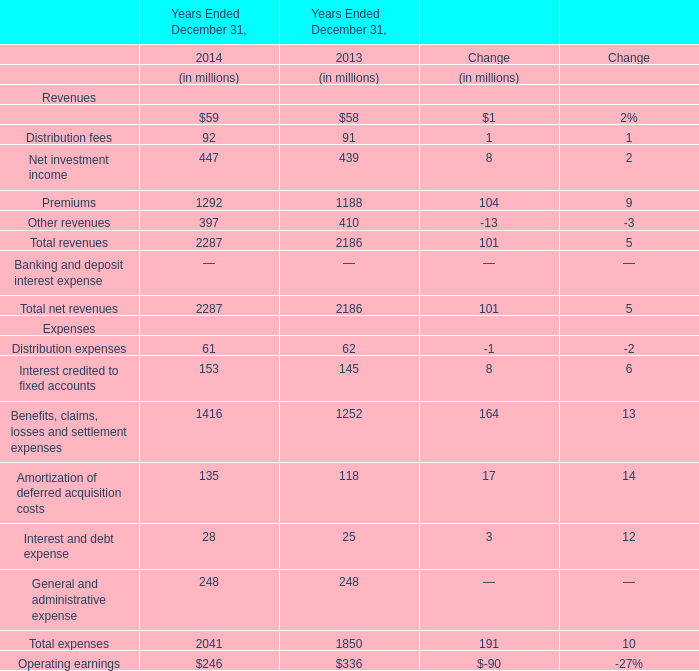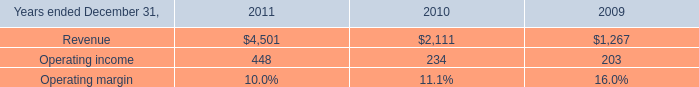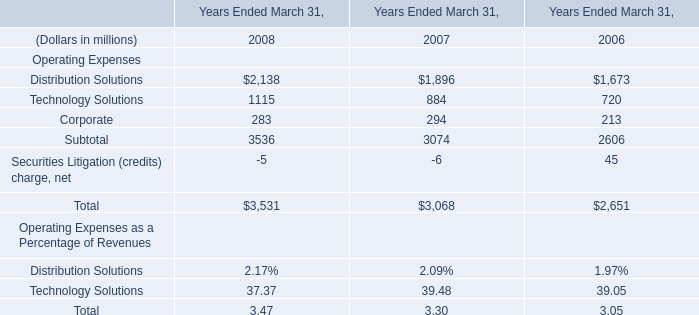what was the percent of the increase in the operating income from 2010 to 2011 
Computations: ((448 - 234) / 234)
Answer: 0.91453. 